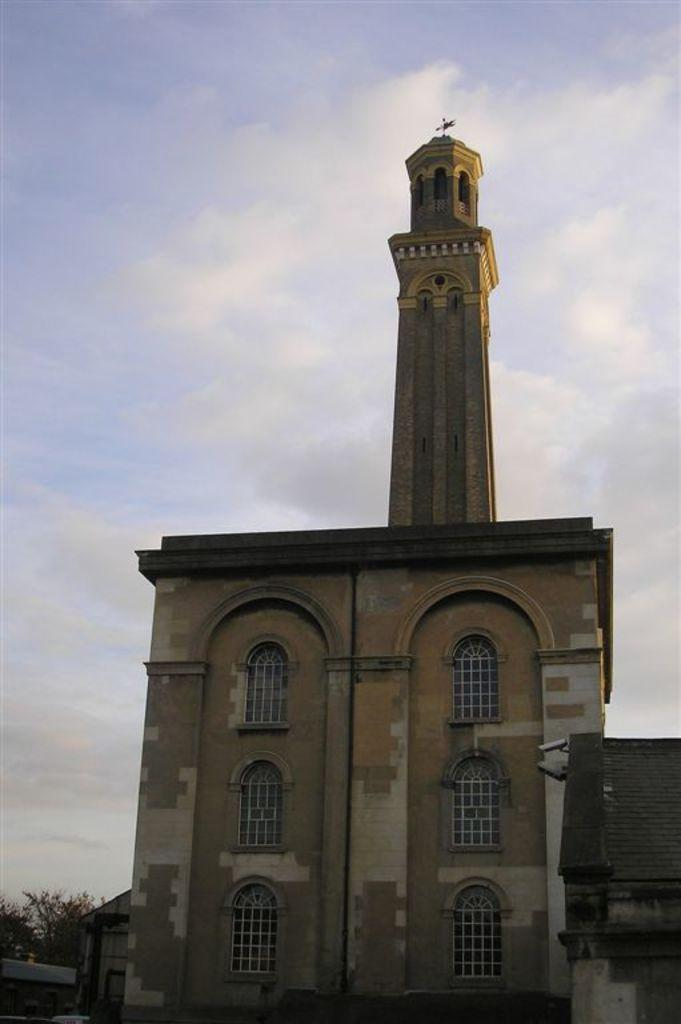What structures are located in the foreground of the image? There are buildings in the foreground of the image. What type of vegetation can be seen in the background of the image? There are trees in the background of the image. What is visible in the sky in the background of the image? The sky is visible in the background of the image, and there is a cloud in the sky. What type of lumber is being used to construct the buildings in the image? There is no information about the type of lumber used in the construction of the buildings in the image. 